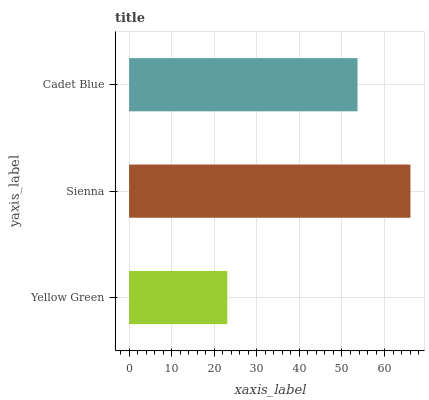Is Yellow Green the minimum?
Answer yes or no. Yes. Is Sienna the maximum?
Answer yes or no. Yes. Is Cadet Blue the minimum?
Answer yes or no. No. Is Cadet Blue the maximum?
Answer yes or no. No. Is Sienna greater than Cadet Blue?
Answer yes or no. Yes. Is Cadet Blue less than Sienna?
Answer yes or no. Yes. Is Cadet Blue greater than Sienna?
Answer yes or no. No. Is Sienna less than Cadet Blue?
Answer yes or no. No. Is Cadet Blue the high median?
Answer yes or no. Yes. Is Cadet Blue the low median?
Answer yes or no. Yes. Is Yellow Green the high median?
Answer yes or no. No. Is Sienna the low median?
Answer yes or no. No. 